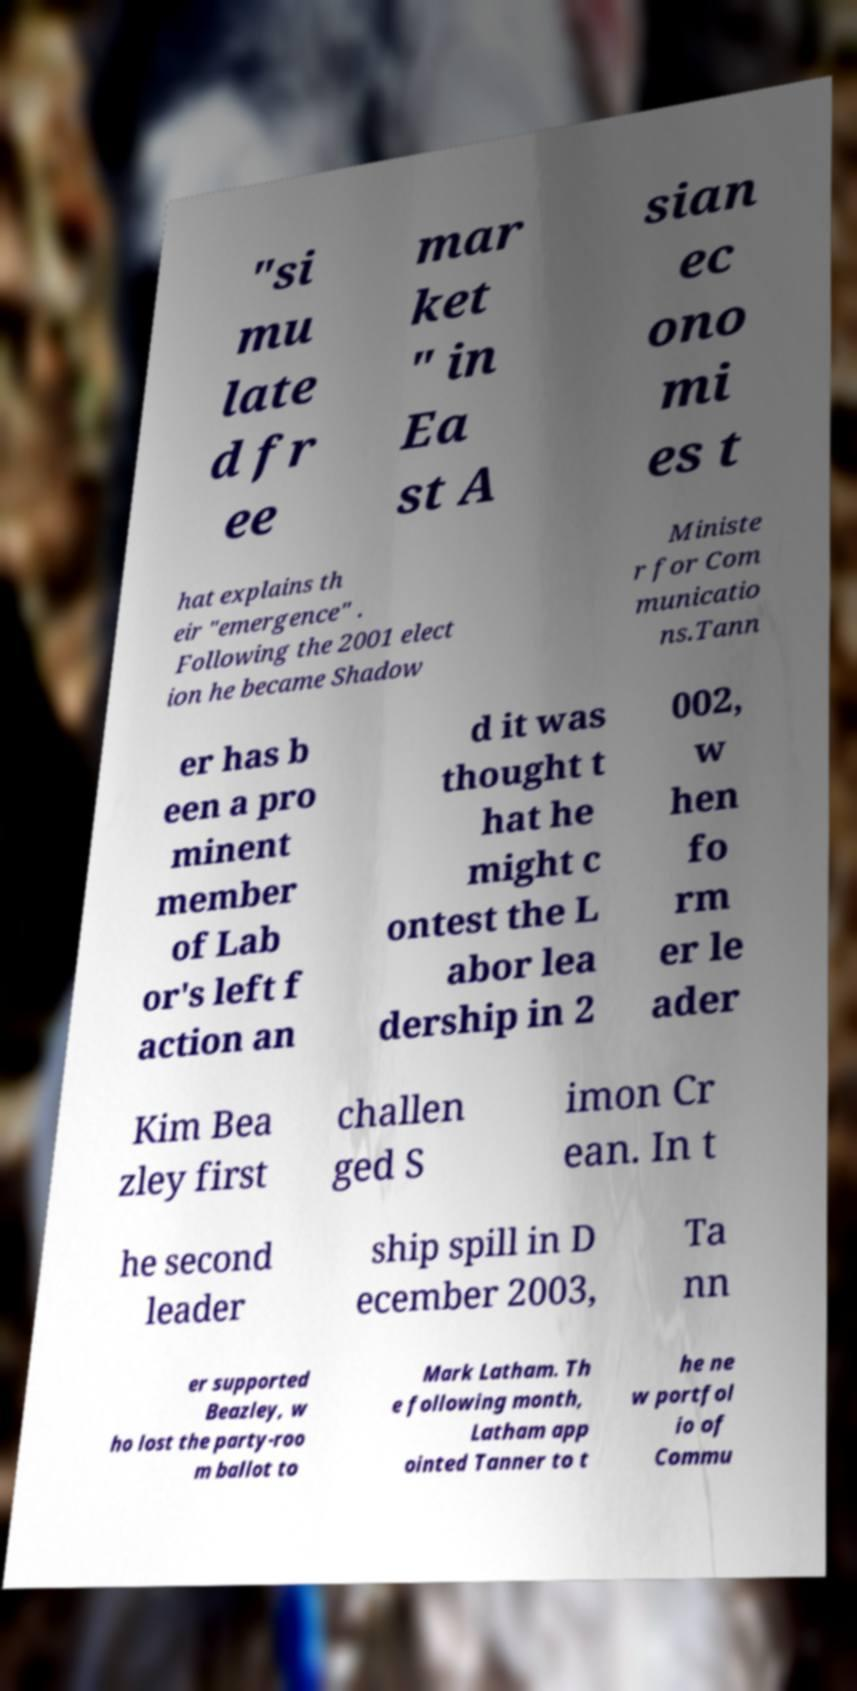Can you accurately transcribe the text from the provided image for me? "si mu late d fr ee mar ket " in Ea st A sian ec ono mi es t hat explains th eir "emergence" . Following the 2001 elect ion he became Shadow Ministe r for Com municatio ns.Tann er has b een a pro minent member of Lab or's left f action an d it was thought t hat he might c ontest the L abor lea dership in 2 002, w hen fo rm er le ader Kim Bea zley first challen ged S imon Cr ean. In t he second leader ship spill in D ecember 2003, Ta nn er supported Beazley, w ho lost the party-roo m ballot to Mark Latham. Th e following month, Latham app ointed Tanner to t he ne w portfol io of Commu 